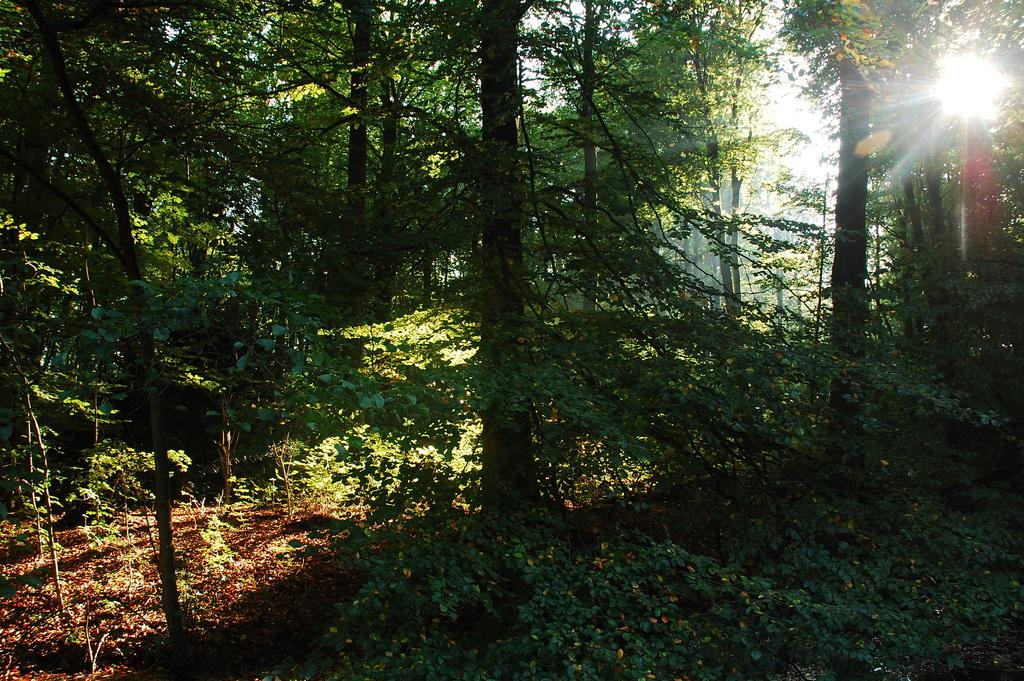What type of vegetation can be seen in the image? There are plants and trees in the image. Can you describe the sky in the image? The sun is visible at the top of the image. What type of corn is being used as bait in the image? There is no corn or bait present in the image; it features plants, trees, and the sun. 